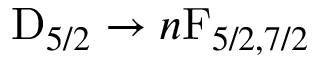<formula> <loc_0><loc_0><loc_500><loc_500>D _ { 5 / 2 } \to n F _ { 5 / 2 , 7 / 2 }</formula> 